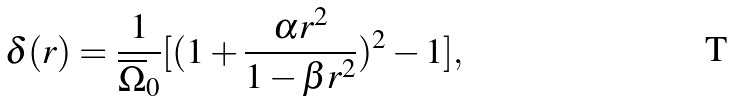Convert formula to latex. <formula><loc_0><loc_0><loc_500><loc_500>\delta ( r ) = \frac { 1 } { \overline { \Omega } _ { 0 } } [ ( 1 + \frac { \alpha r ^ { 2 } } { 1 - \beta r ^ { 2 } } ) ^ { 2 } - 1 ] ,</formula> 